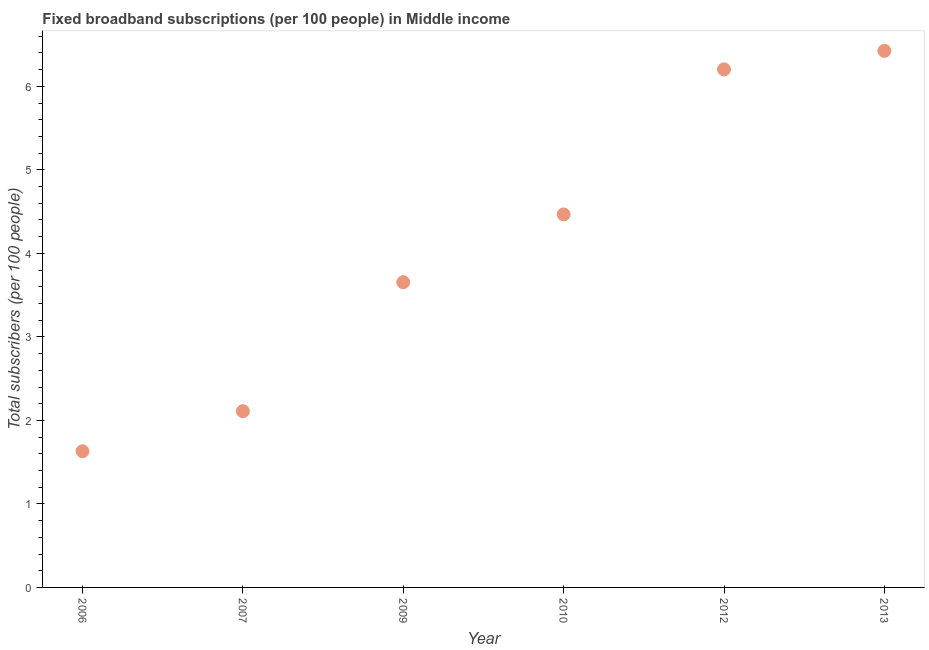What is the total number of fixed broadband subscriptions in 2007?
Keep it short and to the point. 2.11. Across all years, what is the maximum total number of fixed broadband subscriptions?
Give a very brief answer. 6.43. Across all years, what is the minimum total number of fixed broadband subscriptions?
Provide a succinct answer. 1.63. What is the sum of the total number of fixed broadband subscriptions?
Provide a succinct answer. 24.49. What is the difference between the total number of fixed broadband subscriptions in 2007 and 2013?
Your answer should be compact. -4.31. What is the average total number of fixed broadband subscriptions per year?
Provide a short and direct response. 4.08. What is the median total number of fixed broadband subscriptions?
Your answer should be very brief. 4.06. In how many years, is the total number of fixed broadband subscriptions greater than 5.2 ?
Make the answer very short. 2. Do a majority of the years between 2007 and 2012 (inclusive) have total number of fixed broadband subscriptions greater than 1.4 ?
Your response must be concise. Yes. What is the ratio of the total number of fixed broadband subscriptions in 2007 to that in 2013?
Ensure brevity in your answer.  0.33. What is the difference between the highest and the second highest total number of fixed broadband subscriptions?
Offer a terse response. 0.22. Is the sum of the total number of fixed broadband subscriptions in 2012 and 2013 greater than the maximum total number of fixed broadband subscriptions across all years?
Keep it short and to the point. Yes. What is the difference between the highest and the lowest total number of fixed broadband subscriptions?
Offer a very short reply. 4.79. How many dotlines are there?
Your response must be concise. 1. Does the graph contain any zero values?
Ensure brevity in your answer.  No. What is the title of the graph?
Your answer should be compact. Fixed broadband subscriptions (per 100 people) in Middle income. What is the label or title of the X-axis?
Offer a very short reply. Year. What is the label or title of the Y-axis?
Your answer should be very brief. Total subscribers (per 100 people). What is the Total subscribers (per 100 people) in 2006?
Offer a very short reply. 1.63. What is the Total subscribers (per 100 people) in 2007?
Offer a very short reply. 2.11. What is the Total subscribers (per 100 people) in 2009?
Your answer should be very brief. 3.65. What is the Total subscribers (per 100 people) in 2010?
Your answer should be compact. 4.47. What is the Total subscribers (per 100 people) in 2012?
Ensure brevity in your answer.  6.2. What is the Total subscribers (per 100 people) in 2013?
Ensure brevity in your answer.  6.43. What is the difference between the Total subscribers (per 100 people) in 2006 and 2007?
Your answer should be compact. -0.48. What is the difference between the Total subscribers (per 100 people) in 2006 and 2009?
Give a very brief answer. -2.02. What is the difference between the Total subscribers (per 100 people) in 2006 and 2010?
Ensure brevity in your answer.  -2.84. What is the difference between the Total subscribers (per 100 people) in 2006 and 2012?
Offer a very short reply. -4.57. What is the difference between the Total subscribers (per 100 people) in 2006 and 2013?
Offer a terse response. -4.79. What is the difference between the Total subscribers (per 100 people) in 2007 and 2009?
Your response must be concise. -1.54. What is the difference between the Total subscribers (per 100 people) in 2007 and 2010?
Provide a succinct answer. -2.36. What is the difference between the Total subscribers (per 100 people) in 2007 and 2012?
Ensure brevity in your answer.  -4.09. What is the difference between the Total subscribers (per 100 people) in 2007 and 2013?
Ensure brevity in your answer.  -4.31. What is the difference between the Total subscribers (per 100 people) in 2009 and 2010?
Your response must be concise. -0.81. What is the difference between the Total subscribers (per 100 people) in 2009 and 2012?
Ensure brevity in your answer.  -2.55. What is the difference between the Total subscribers (per 100 people) in 2009 and 2013?
Offer a terse response. -2.77. What is the difference between the Total subscribers (per 100 people) in 2010 and 2012?
Your answer should be compact. -1.74. What is the difference between the Total subscribers (per 100 people) in 2010 and 2013?
Your answer should be very brief. -1.96. What is the difference between the Total subscribers (per 100 people) in 2012 and 2013?
Offer a terse response. -0.22. What is the ratio of the Total subscribers (per 100 people) in 2006 to that in 2007?
Offer a very short reply. 0.77. What is the ratio of the Total subscribers (per 100 people) in 2006 to that in 2009?
Offer a very short reply. 0.45. What is the ratio of the Total subscribers (per 100 people) in 2006 to that in 2010?
Keep it short and to the point. 0.36. What is the ratio of the Total subscribers (per 100 people) in 2006 to that in 2012?
Offer a terse response. 0.26. What is the ratio of the Total subscribers (per 100 people) in 2006 to that in 2013?
Provide a short and direct response. 0.25. What is the ratio of the Total subscribers (per 100 people) in 2007 to that in 2009?
Offer a terse response. 0.58. What is the ratio of the Total subscribers (per 100 people) in 2007 to that in 2010?
Provide a succinct answer. 0.47. What is the ratio of the Total subscribers (per 100 people) in 2007 to that in 2012?
Offer a terse response. 0.34. What is the ratio of the Total subscribers (per 100 people) in 2007 to that in 2013?
Your answer should be compact. 0.33. What is the ratio of the Total subscribers (per 100 people) in 2009 to that in 2010?
Your answer should be compact. 0.82. What is the ratio of the Total subscribers (per 100 people) in 2009 to that in 2012?
Give a very brief answer. 0.59. What is the ratio of the Total subscribers (per 100 people) in 2009 to that in 2013?
Offer a terse response. 0.57. What is the ratio of the Total subscribers (per 100 people) in 2010 to that in 2012?
Offer a very short reply. 0.72. What is the ratio of the Total subscribers (per 100 people) in 2010 to that in 2013?
Your response must be concise. 0.69. 